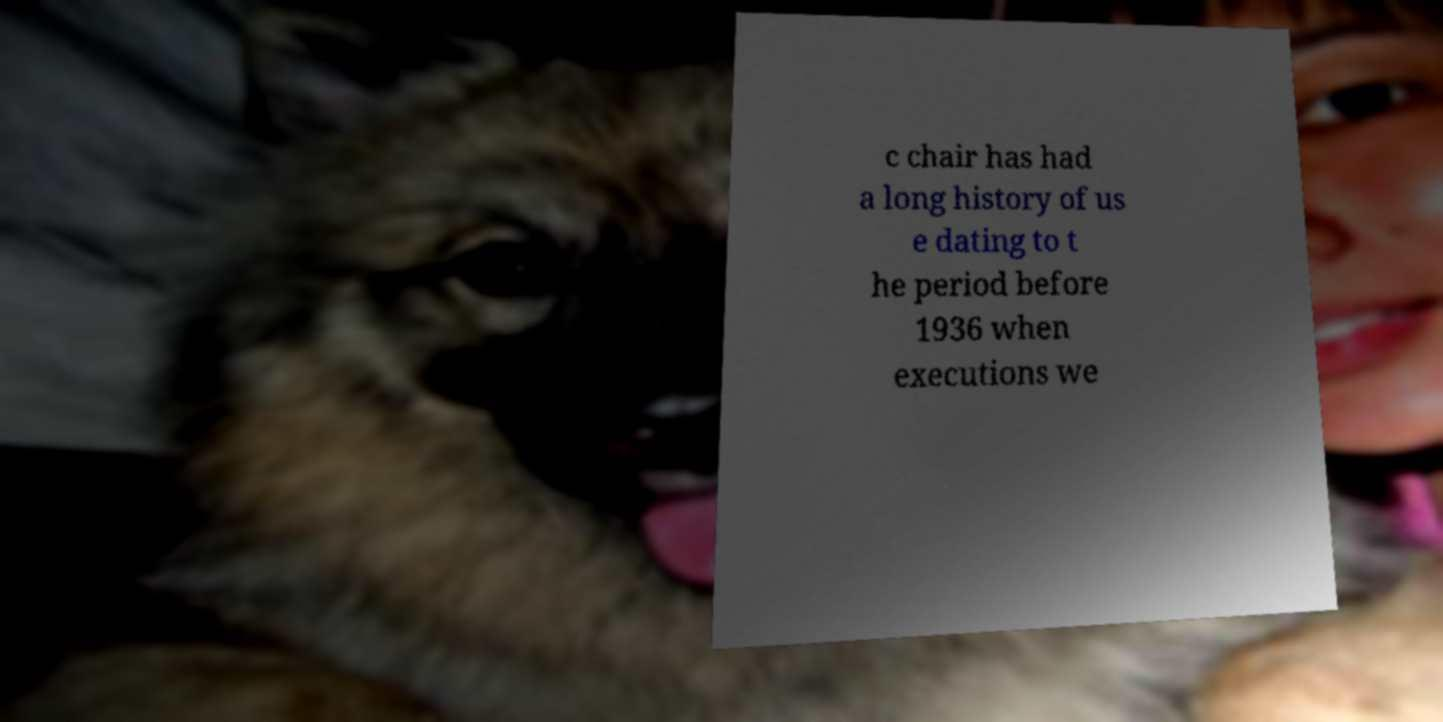There's text embedded in this image that I need extracted. Can you transcribe it verbatim? c chair has had a long history of us e dating to t he period before 1936 when executions we 